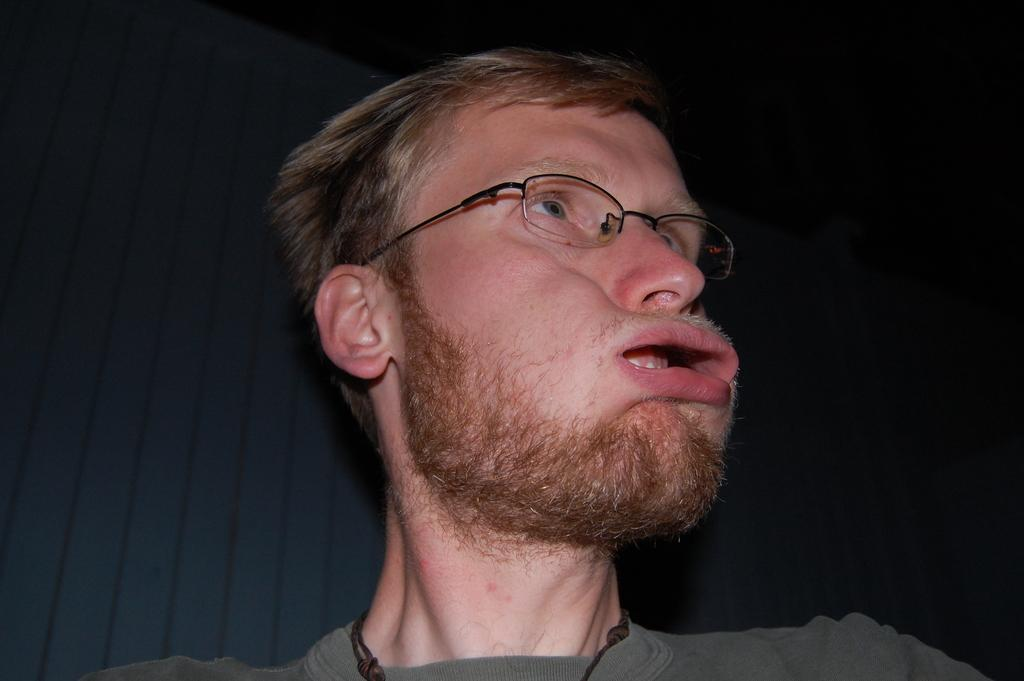Who or what is the main subject in the image? There is a person in the center of the image. What can be observed about the person's appearance? The person is wearing spectacles. What can be seen in the background of the image? There is a wall in the background of the image. What type of dinosaurs can be seen in the image? There are no dinosaurs present in the image; it features a person wearing spectacles. How does the ray interact with the person in the image? There is no ray present in the image; it only features a person wearing spectacles and a wall in the background. 